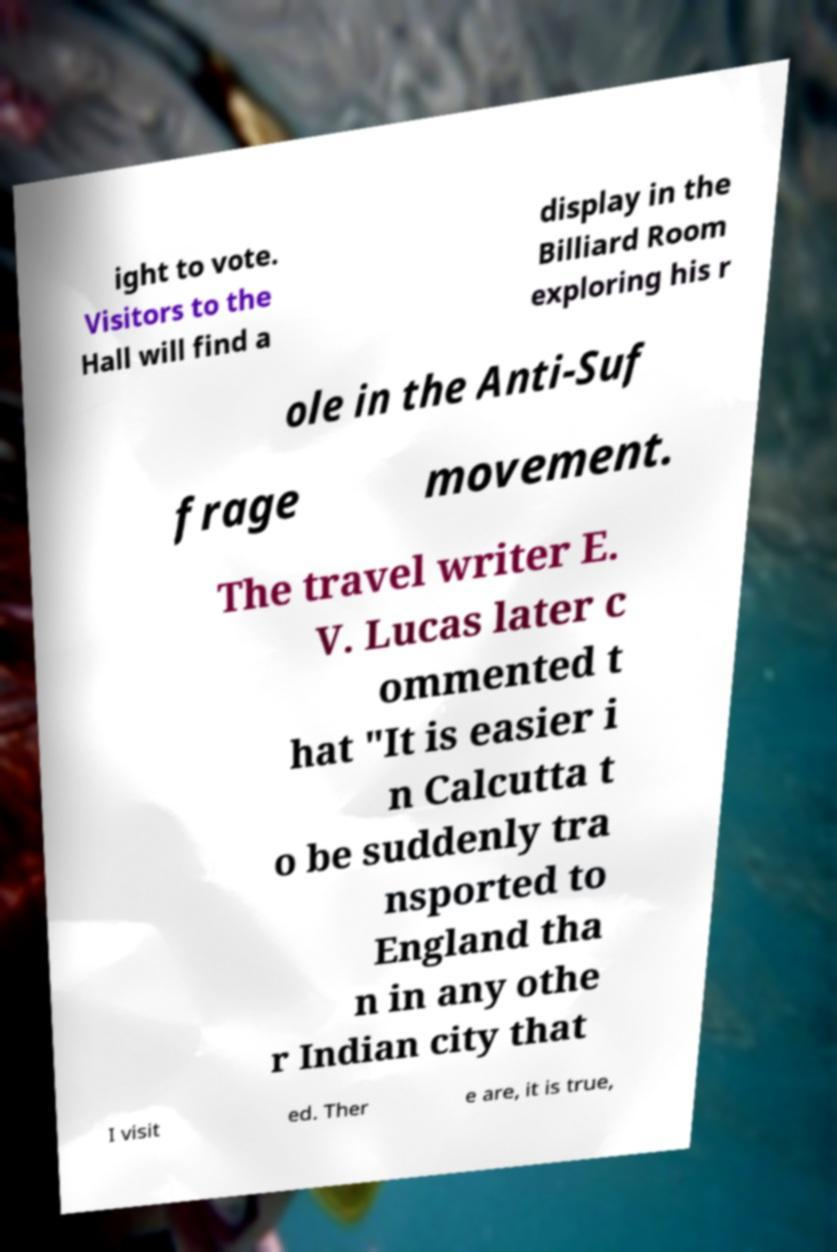Can you read and provide the text displayed in the image?This photo seems to have some interesting text. Can you extract and type it out for me? ight to vote. Visitors to the Hall will find a display in the Billiard Room exploring his r ole in the Anti-Suf frage movement. The travel writer E. V. Lucas later c ommented t hat "It is easier i n Calcutta t o be suddenly tra nsported to England tha n in any othe r Indian city that I visit ed. Ther e are, it is true, 